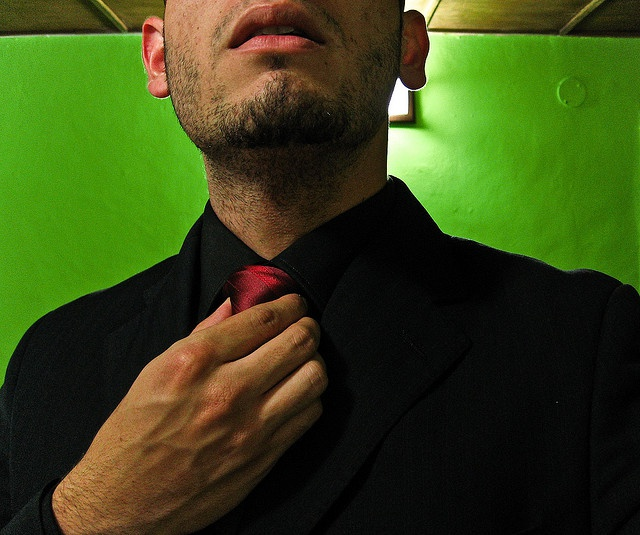Describe the objects in this image and their specific colors. I can see people in black, darkgreen, maroon, and brown tones and tie in darkgreen, black, maroon, and brown tones in this image. 